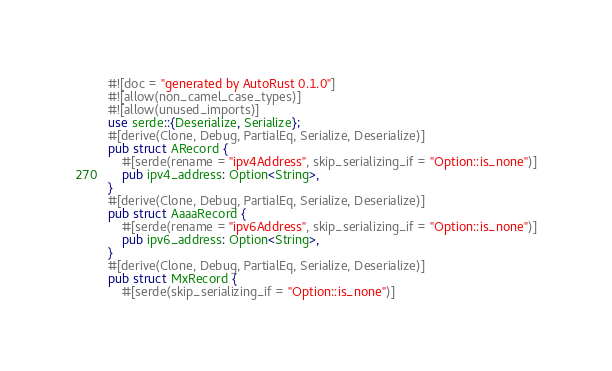Convert code to text. <code><loc_0><loc_0><loc_500><loc_500><_Rust_>#![doc = "generated by AutoRust 0.1.0"]
#![allow(non_camel_case_types)]
#![allow(unused_imports)]
use serde::{Deserialize, Serialize};
#[derive(Clone, Debug, PartialEq, Serialize, Deserialize)]
pub struct ARecord {
    #[serde(rename = "ipv4Address", skip_serializing_if = "Option::is_none")]
    pub ipv4_address: Option<String>,
}
#[derive(Clone, Debug, PartialEq, Serialize, Deserialize)]
pub struct AaaaRecord {
    #[serde(rename = "ipv6Address", skip_serializing_if = "Option::is_none")]
    pub ipv6_address: Option<String>,
}
#[derive(Clone, Debug, PartialEq, Serialize, Deserialize)]
pub struct MxRecord {
    #[serde(skip_serializing_if = "Option::is_none")]</code> 